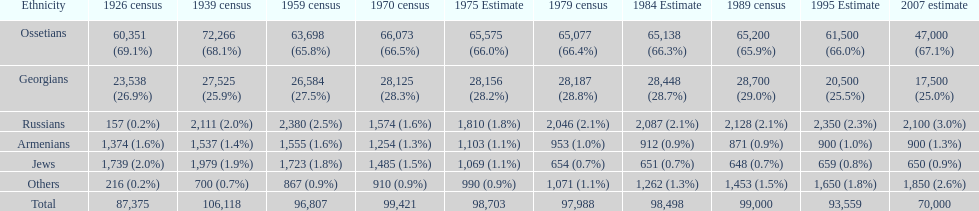Who is previous of the russians based on the list? Georgians. 